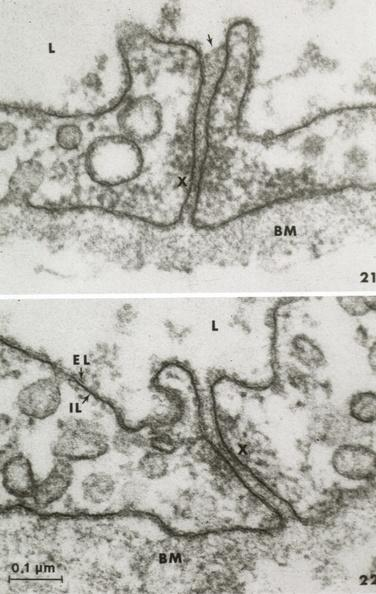s vasculature present?
Answer the question using a single word or phrase. Yes 